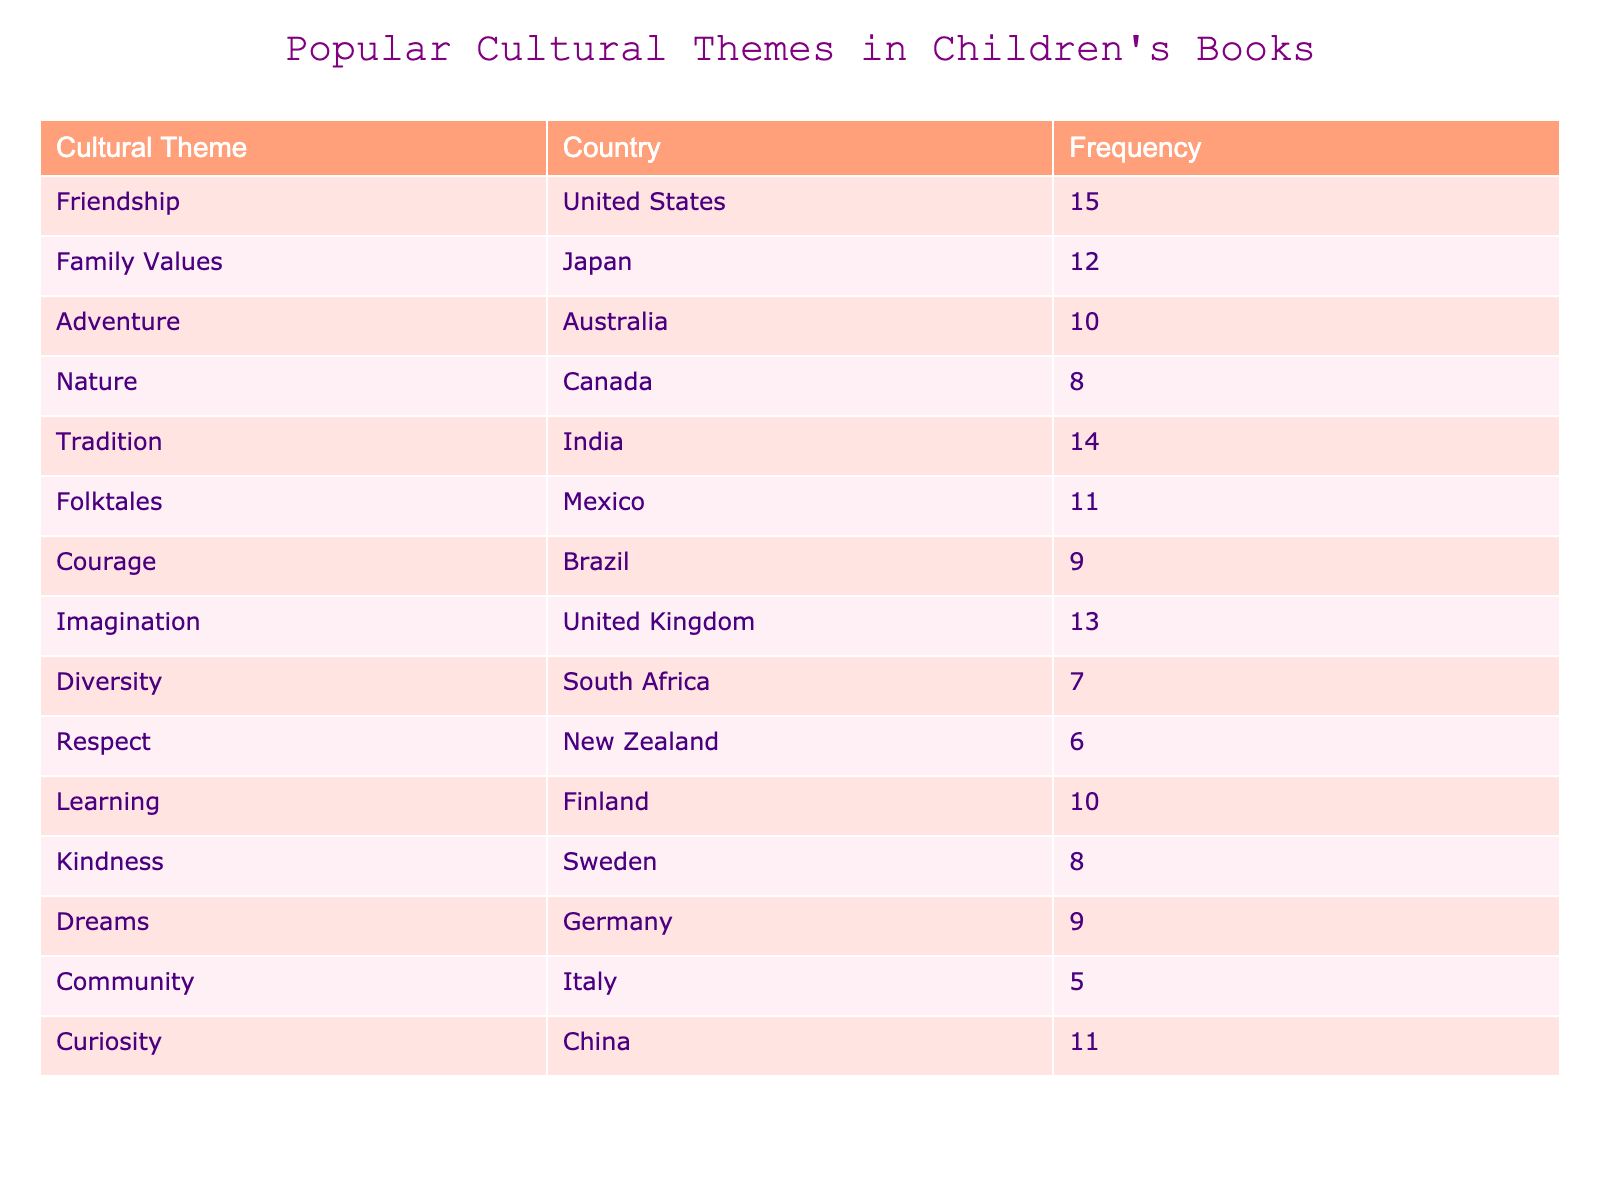What is the frequency of the "Imagination" theme in children's books? The table indicates that the "Imagination" theme has a frequency of 13 in children's books from the United Kingdom.
Answer: 13 Which cultural theme has the highest frequency? By examining the table, we see that "Friendship" has the highest frequency with a value of 15 from the United States.
Answer: Friendship How many countries have a frequency of 10 or more? There are 6 themes with a frequency of 10 or more: Friendship (15), Tradition (14), Imagination (13), Family Values (12), Curiosity (11), and Folktales (11), making a total of 6.
Answer: 6 What is the total frequency of the themes related to community values (Family Values, Community, and Kindness)? We sum the frequencies of Family Values (12), Community (5), and Kindness (8): 12 + 5 + 8 = 25.
Answer: 25 Is there a theme related to courage, and what is its frequency? Yes, the table shows that "Courage" is a theme from Brazil with a frequency of 9.
Answer: Yes, 9 What is the average frequency of all cultural themes listed? To find the average, we sum all the frequencies: 15 + 12 + 10 + 8 + 14 + 11 + 9 + 13 + 7 + 6 + 10 + 8 + 9 + 5 + 11 =  5 frequencies. A total of 15 themes gives: 15 + 12 + 10 + 8 + 14 + 11 + 9 + 13 + 7 + 6 + 10 + 8 + 9 + 5 + 11 = 15 themes. Total divided by number of themes (15) equals an average of 10.
Answer: 10 What cultural theme has a low frequency in children's books, and which country does it come from? "Community" stands out with the lowest frequency at 5, and it originates from Italy.
Answer: Community, Italy Which themes come from South America? The table indicates that the themes from South America are "Courage" from Brazil.
Answer: Courage, Brazil 